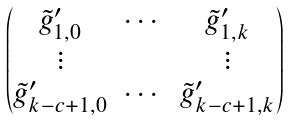Convert formula to latex. <formula><loc_0><loc_0><loc_500><loc_500>\begin{pmatrix} \tilde { g } ^ { \prime } _ { 1 , 0 } & \cdots & \tilde { g } ^ { \prime } _ { 1 , k } \\ \vdots & & \vdots \\ \tilde { g } ^ { \prime } _ { k - c + 1 , 0 } & \cdots & \tilde { g } ^ { \prime } _ { k - c + 1 , k } \end{pmatrix}</formula> 